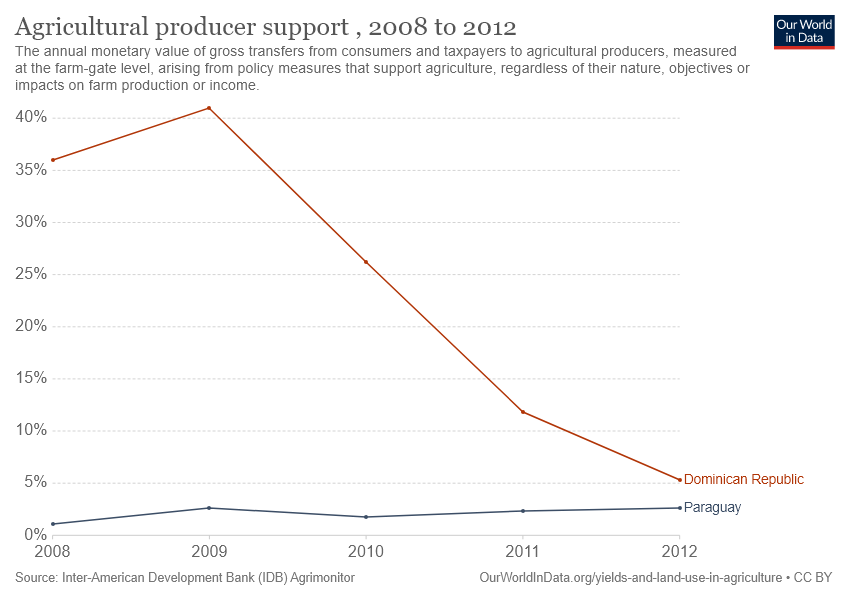List a handful of essential elements in this visual. The Dominican Republic recorded the highest agricultural producer support in 2009. The blue line in the graph represents a country, which is Paraguay. 